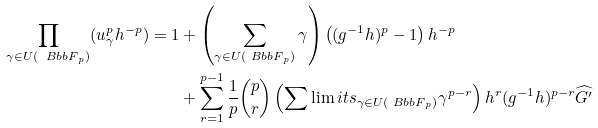Convert formula to latex. <formula><loc_0><loc_0><loc_500><loc_500>\prod _ { \gamma \in U ( { \ B b b F } _ { p } ) } ( u _ { \gamma } ^ { p } h ^ { - p } ) = 1 & + \left ( \sum _ { \gamma \in U ( { \ B b b F } _ { p } ) } \gamma \right ) \left ( ( g ^ { - 1 } h ) ^ { p } - 1 \right ) h ^ { - p } \\ & + \sum _ { r = 1 } ^ { p - 1 } \frac { 1 } { p } \binom { p } { r } \left ( \sum \lim i t s _ { \gamma \in U ( { \ B b b F } _ { p } ) } \gamma ^ { p - r } \right ) h ^ { r } ( g ^ { - 1 } h ) ^ { p - r } \widehat { G ^ { \prime } }</formula> 